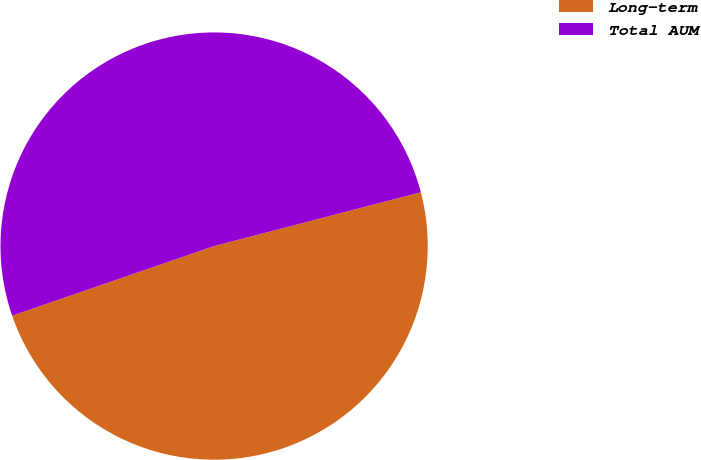<chart> <loc_0><loc_0><loc_500><loc_500><pie_chart><fcel>Long-term<fcel>Total AUM<nl><fcel>48.77%<fcel>51.23%<nl></chart> 